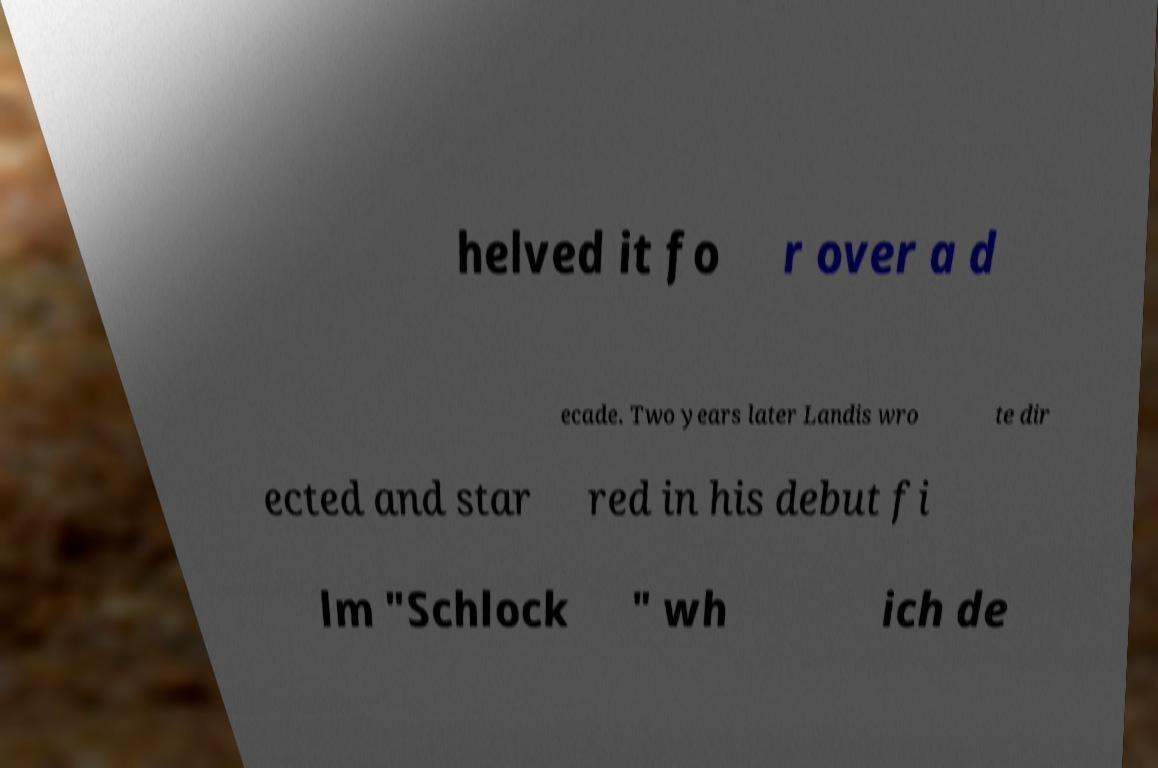There's text embedded in this image that I need extracted. Can you transcribe it verbatim? helved it fo r over a d ecade. Two years later Landis wro te dir ected and star red in his debut fi lm "Schlock " wh ich de 